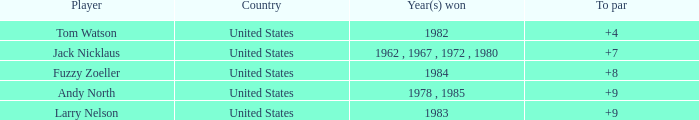What is the to par of player andy north with a total greater than 153? 0.0. 